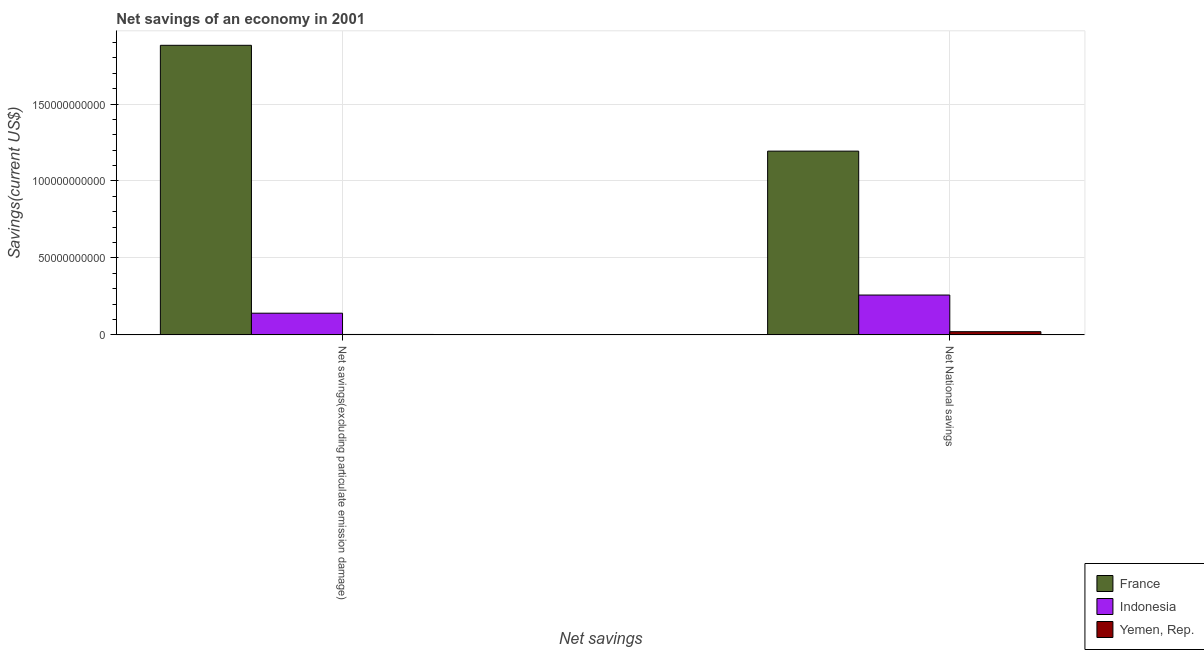How many bars are there on the 1st tick from the right?
Give a very brief answer. 3. What is the label of the 1st group of bars from the left?
Make the answer very short. Net savings(excluding particulate emission damage). What is the net national savings in Yemen, Rep.?
Provide a succinct answer. 2.09e+09. Across all countries, what is the maximum net national savings?
Make the answer very short. 1.19e+11. Across all countries, what is the minimum net savings(excluding particulate emission damage)?
Provide a short and direct response. 2.80e+08. In which country was the net national savings maximum?
Your response must be concise. France. In which country was the net national savings minimum?
Offer a terse response. Yemen, Rep. What is the total net national savings in the graph?
Provide a succinct answer. 1.47e+11. What is the difference between the net savings(excluding particulate emission damage) in Indonesia and that in Yemen, Rep.?
Your answer should be very brief. 1.38e+1. What is the difference between the net national savings in France and the net savings(excluding particulate emission damage) in Indonesia?
Provide a succinct answer. 1.05e+11. What is the average net national savings per country?
Your answer should be compact. 4.91e+1. What is the difference between the net savings(excluding particulate emission damage) and net national savings in Indonesia?
Make the answer very short. -1.18e+1. What is the ratio of the net savings(excluding particulate emission damage) in Yemen, Rep. to that in France?
Provide a succinct answer. 0. In how many countries, is the net national savings greater than the average net national savings taken over all countries?
Provide a short and direct response. 1. What does the 3rd bar from the left in Net savings(excluding particulate emission damage) represents?
Ensure brevity in your answer.  Yemen, Rep. What does the 3rd bar from the right in Net National savings represents?
Give a very brief answer. France. Are all the bars in the graph horizontal?
Offer a very short reply. No. Are the values on the major ticks of Y-axis written in scientific E-notation?
Offer a very short reply. No. Does the graph contain any zero values?
Your answer should be compact. No. Does the graph contain grids?
Your answer should be compact. Yes. Where does the legend appear in the graph?
Provide a short and direct response. Bottom right. How are the legend labels stacked?
Your response must be concise. Vertical. What is the title of the graph?
Offer a terse response. Net savings of an economy in 2001. What is the label or title of the X-axis?
Your answer should be very brief. Net savings. What is the label or title of the Y-axis?
Your answer should be very brief. Savings(current US$). What is the Savings(current US$) of France in Net savings(excluding particulate emission damage)?
Your answer should be very brief. 1.88e+11. What is the Savings(current US$) in Indonesia in Net savings(excluding particulate emission damage)?
Make the answer very short. 1.41e+1. What is the Savings(current US$) in Yemen, Rep. in Net savings(excluding particulate emission damage)?
Provide a short and direct response. 2.80e+08. What is the Savings(current US$) in France in Net National savings?
Your answer should be compact. 1.19e+11. What is the Savings(current US$) in Indonesia in Net National savings?
Give a very brief answer. 2.59e+1. What is the Savings(current US$) in Yemen, Rep. in Net National savings?
Ensure brevity in your answer.  2.09e+09. Across all Net savings, what is the maximum Savings(current US$) of France?
Keep it short and to the point. 1.88e+11. Across all Net savings, what is the maximum Savings(current US$) of Indonesia?
Offer a very short reply. 2.59e+1. Across all Net savings, what is the maximum Savings(current US$) of Yemen, Rep.?
Offer a very short reply. 2.09e+09. Across all Net savings, what is the minimum Savings(current US$) in France?
Give a very brief answer. 1.19e+11. Across all Net savings, what is the minimum Savings(current US$) in Indonesia?
Offer a very short reply. 1.41e+1. Across all Net savings, what is the minimum Savings(current US$) in Yemen, Rep.?
Offer a very short reply. 2.80e+08. What is the total Savings(current US$) of France in the graph?
Your response must be concise. 3.08e+11. What is the total Savings(current US$) of Indonesia in the graph?
Offer a terse response. 4.00e+1. What is the total Savings(current US$) in Yemen, Rep. in the graph?
Offer a terse response. 2.37e+09. What is the difference between the Savings(current US$) in France in Net savings(excluding particulate emission damage) and that in Net National savings?
Give a very brief answer. 6.88e+1. What is the difference between the Savings(current US$) of Indonesia in Net savings(excluding particulate emission damage) and that in Net National savings?
Your answer should be compact. -1.18e+1. What is the difference between the Savings(current US$) in Yemen, Rep. in Net savings(excluding particulate emission damage) and that in Net National savings?
Provide a succinct answer. -1.81e+09. What is the difference between the Savings(current US$) in France in Net savings(excluding particulate emission damage) and the Savings(current US$) in Indonesia in Net National savings?
Your answer should be compact. 1.62e+11. What is the difference between the Savings(current US$) of France in Net savings(excluding particulate emission damage) and the Savings(current US$) of Yemen, Rep. in Net National savings?
Provide a succinct answer. 1.86e+11. What is the difference between the Savings(current US$) in Indonesia in Net savings(excluding particulate emission damage) and the Savings(current US$) in Yemen, Rep. in Net National savings?
Provide a short and direct response. 1.20e+1. What is the average Savings(current US$) in France per Net savings?
Offer a very short reply. 1.54e+11. What is the average Savings(current US$) of Indonesia per Net savings?
Your answer should be very brief. 2.00e+1. What is the average Savings(current US$) of Yemen, Rep. per Net savings?
Offer a very short reply. 1.18e+09. What is the difference between the Savings(current US$) in France and Savings(current US$) in Indonesia in Net savings(excluding particulate emission damage)?
Provide a succinct answer. 1.74e+11. What is the difference between the Savings(current US$) in France and Savings(current US$) in Yemen, Rep. in Net savings(excluding particulate emission damage)?
Give a very brief answer. 1.88e+11. What is the difference between the Savings(current US$) in Indonesia and Savings(current US$) in Yemen, Rep. in Net savings(excluding particulate emission damage)?
Give a very brief answer. 1.38e+1. What is the difference between the Savings(current US$) in France and Savings(current US$) in Indonesia in Net National savings?
Keep it short and to the point. 9.35e+1. What is the difference between the Savings(current US$) in France and Savings(current US$) in Yemen, Rep. in Net National savings?
Make the answer very short. 1.17e+11. What is the difference between the Savings(current US$) in Indonesia and Savings(current US$) in Yemen, Rep. in Net National savings?
Offer a terse response. 2.38e+1. What is the ratio of the Savings(current US$) in France in Net savings(excluding particulate emission damage) to that in Net National savings?
Ensure brevity in your answer.  1.58. What is the ratio of the Savings(current US$) in Indonesia in Net savings(excluding particulate emission damage) to that in Net National savings?
Offer a very short reply. 0.54. What is the ratio of the Savings(current US$) in Yemen, Rep. in Net savings(excluding particulate emission damage) to that in Net National savings?
Offer a very short reply. 0.13. What is the difference between the highest and the second highest Savings(current US$) in France?
Give a very brief answer. 6.88e+1. What is the difference between the highest and the second highest Savings(current US$) of Indonesia?
Make the answer very short. 1.18e+1. What is the difference between the highest and the second highest Savings(current US$) of Yemen, Rep.?
Provide a short and direct response. 1.81e+09. What is the difference between the highest and the lowest Savings(current US$) of France?
Offer a very short reply. 6.88e+1. What is the difference between the highest and the lowest Savings(current US$) in Indonesia?
Your response must be concise. 1.18e+1. What is the difference between the highest and the lowest Savings(current US$) in Yemen, Rep.?
Make the answer very short. 1.81e+09. 